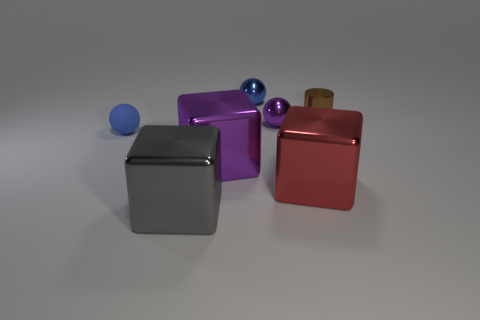Add 1 brown cylinders. How many objects exist? 8 Subtract all cylinders. How many objects are left? 6 Subtract all small gray cylinders. Subtract all red metallic blocks. How many objects are left? 6 Add 4 large cubes. How many large cubes are left? 7 Add 1 big gray cubes. How many big gray cubes exist? 2 Subtract 0 yellow cylinders. How many objects are left? 7 